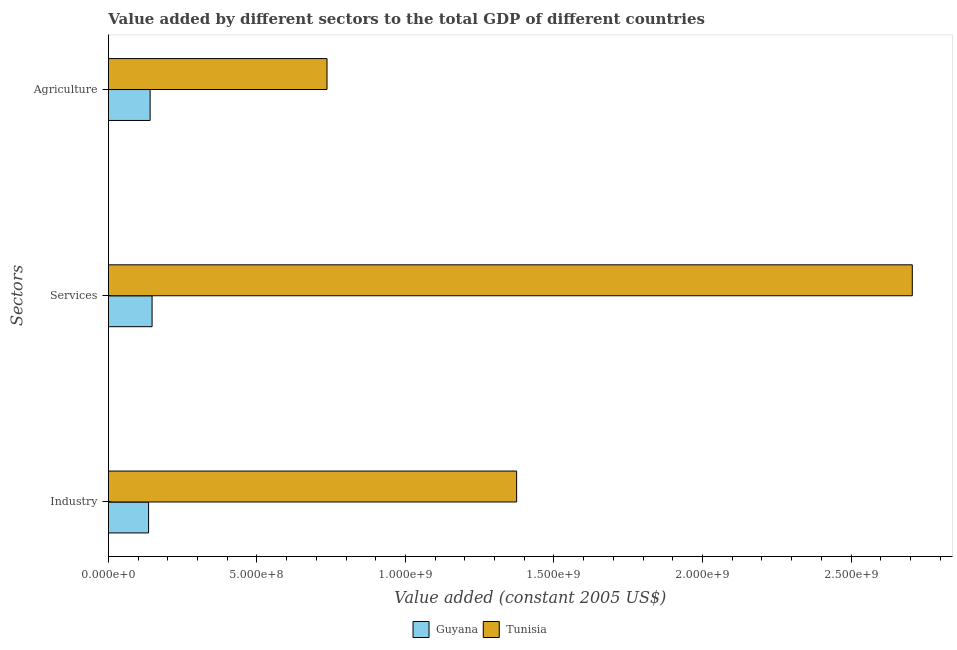How many groups of bars are there?
Offer a very short reply. 3. Are the number of bars per tick equal to the number of legend labels?
Your answer should be very brief. Yes. Are the number of bars on each tick of the Y-axis equal?
Make the answer very short. Yes. How many bars are there on the 3rd tick from the bottom?
Your answer should be very brief. 2. What is the label of the 3rd group of bars from the top?
Ensure brevity in your answer.  Industry. What is the value added by agricultural sector in Guyana?
Ensure brevity in your answer.  1.40e+08. Across all countries, what is the maximum value added by services?
Offer a very short reply. 2.71e+09. Across all countries, what is the minimum value added by industrial sector?
Provide a short and direct response. 1.35e+08. In which country was the value added by industrial sector maximum?
Keep it short and to the point. Tunisia. In which country was the value added by services minimum?
Make the answer very short. Guyana. What is the total value added by industrial sector in the graph?
Keep it short and to the point. 1.51e+09. What is the difference between the value added by agricultural sector in Guyana and that in Tunisia?
Keep it short and to the point. -5.96e+08. What is the difference between the value added by industrial sector in Guyana and the value added by services in Tunisia?
Your response must be concise. -2.57e+09. What is the average value added by agricultural sector per country?
Offer a very short reply. 4.38e+08. What is the difference between the value added by services and value added by industrial sector in Tunisia?
Make the answer very short. 1.33e+09. In how many countries, is the value added by industrial sector greater than 600000000 US$?
Give a very brief answer. 1. What is the ratio of the value added by services in Tunisia to that in Guyana?
Provide a short and direct response. 18.41. Is the value added by services in Tunisia less than that in Guyana?
Offer a terse response. No. What is the difference between the highest and the second highest value added by services?
Provide a succinct answer. 2.56e+09. What is the difference between the highest and the lowest value added by industrial sector?
Make the answer very short. 1.24e+09. In how many countries, is the value added by agricultural sector greater than the average value added by agricultural sector taken over all countries?
Ensure brevity in your answer.  1. What does the 1st bar from the top in Services represents?
Your answer should be compact. Tunisia. What does the 2nd bar from the bottom in Services represents?
Your answer should be compact. Tunisia. Are all the bars in the graph horizontal?
Provide a short and direct response. Yes. Are the values on the major ticks of X-axis written in scientific E-notation?
Provide a short and direct response. Yes. Does the graph contain grids?
Ensure brevity in your answer.  No. Where does the legend appear in the graph?
Offer a terse response. Bottom center. How many legend labels are there?
Your answer should be compact. 2. What is the title of the graph?
Provide a short and direct response. Value added by different sectors to the total GDP of different countries. What is the label or title of the X-axis?
Your answer should be compact. Value added (constant 2005 US$). What is the label or title of the Y-axis?
Your answer should be very brief. Sectors. What is the Value added (constant 2005 US$) in Guyana in Industry?
Provide a succinct answer. 1.35e+08. What is the Value added (constant 2005 US$) in Tunisia in Industry?
Provide a short and direct response. 1.37e+09. What is the Value added (constant 2005 US$) of Guyana in Services?
Provide a succinct answer. 1.47e+08. What is the Value added (constant 2005 US$) of Tunisia in Services?
Provide a succinct answer. 2.71e+09. What is the Value added (constant 2005 US$) of Guyana in Agriculture?
Ensure brevity in your answer.  1.40e+08. What is the Value added (constant 2005 US$) of Tunisia in Agriculture?
Make the answer very short. 7.36e+08. Across all Sectors, what is the maximum Value added (constant 2005 US$) of Guyana?
Ensure brevity in your answer.  1.47e+08. Across all Sectors, what is the maximum Value added (constant 2005 US$) in Tunisia?
Your answer should be very brief. 2.71e+09. Across all Sectors, what is the minimum Value added (constant 2005 US$) of Guyana?
Ensure brevity in your answer.  1.35e+08. Across all Sectors, what is the minimum Value added (constant 2005 US$) of Tunisia?
Offer a very short reply. 7.36e+08. What is the total Value added (constant 2005 US$) of Guyana in the graph?
Offer a very short reply. 4.23e+08. What is the total Value added (constant 2005 US$) in Tunisia in the graph?
Your response must be concise. 4.82e+09. What is the difference between the Value added (constant 2005 US$) in Guyana in Industry and that in Services?
Offer a terse response. -1.18e+07. What is the difference between the Value added (constant 2005 US$) of Tunisia in Industry and that in Services?
Provide a succinct answer. -1.33e+09. What is the difference between the Value added (constant 2005 US$) in Guyana in Industry and that in Agriculture?
Your answer should be compact. -5.15e+06. What is the difference between the Value added (constant 2005 US$) of Tunisia in Industry and that in Agriculture?
Provide a short and direct response. 6.38e+08. What is the difference between the Value added (constant 2005 US$) of Guyana in Services and that in Agriculture?
Your answer should be very brief. 6.61e+06. What is the difference between the Value added (constant 2005 US$) of Tunisia in Services and that in Agriculture?
Make the answer very short. 1.97e+09. What is the difference between the Value added (constant 2005 US$) of Guyana in Industry and the Value added (constant 2005 US$) of Tunisia in Services?
Make the answer very short. -2.57e+09. What is the difference between the Value added (constant 2005 US$) of Guyana in Industry and the Value added (constant 2005 US$) of Tunisia in Agriculture?
Provide a succinct answer. -6.01e+08. What is the difference between the Value added (constant 2005 US$) of Guyana in Services and the Value added (constant 2005 US$) of Tunisia in Agriculture?
Provide a short and direct response. -5.89e+08. What is the average Value added (constant 2005 US$) in Guyana per Sectors?
Offer a very short reply. 1.41e+08. What is the average Value added (constant 2005 US$) in Tunisia per Sectors?
Your response must be concise. 1.61e+09. What is the difference between the Value added (constant 2005 US$) of Guyana and Value added (constant 2005 US$) of Tunisia in Industry?
Give a very brief answer. -1.24e+09. What is the difference between the Value added (constant 2005 US$) of Guyana and Value added (constant 2005 US$) of Tunisia in Services?
Provide a short and direct response. -2.56e+09. What is the difference between the Value added (constant 2005 US$) in Guyana and Value added (constant 2005 US$) in Tunisia in Agriculture?
Make the answer very short. -5.96e+08. What is the ratio of the Value added (constant 2005 US$) of Guyana in Industry to that in Services?
Offer a terse response. 0.92. What is the ratio of the Value added (constant 2005 US$) in Tunisia in Industry to that in Services?
Make the answer very short. 0.51. What is the ratio of the Value added (constant 2005 US$) in Guyana in Industry to that in Agriculture?
Make the answer very short. 0.96. What is the ratio of the Value added (constant 2005 US$) in Tunisia in Industry to that in Agriculture?
Your answer should be very brief. 1.87. What is the ratio of the Value added (constant 2005 US$) in Guyana in Services to that in Agriculture?
Give a very brief answer. 1.05. What is the ratio of the Value added (constant 2005 US$) in Tunisia in Services to that in Agriculture?
Your answer should be compact. 3.68. What is the difference between the highest and the second highest Value added (constant 2005 US$) of Guyana?
Offer a terse response. 6.61e+06. What is the difference between the highest and the second highest Value added (constant 2005 US$) of Tunisia?
Make the answer very short. 1.33e+09. What is the difference between the highest and the lowest Value added (constant 2005 US$) in Guyana?
Provide a short and direct response. 1.18e+07. What is the difference between the highest and the lowest Value added (constant 2005 US$) in Tunisia?
Keep it short and to the point. 1.97e+09. 